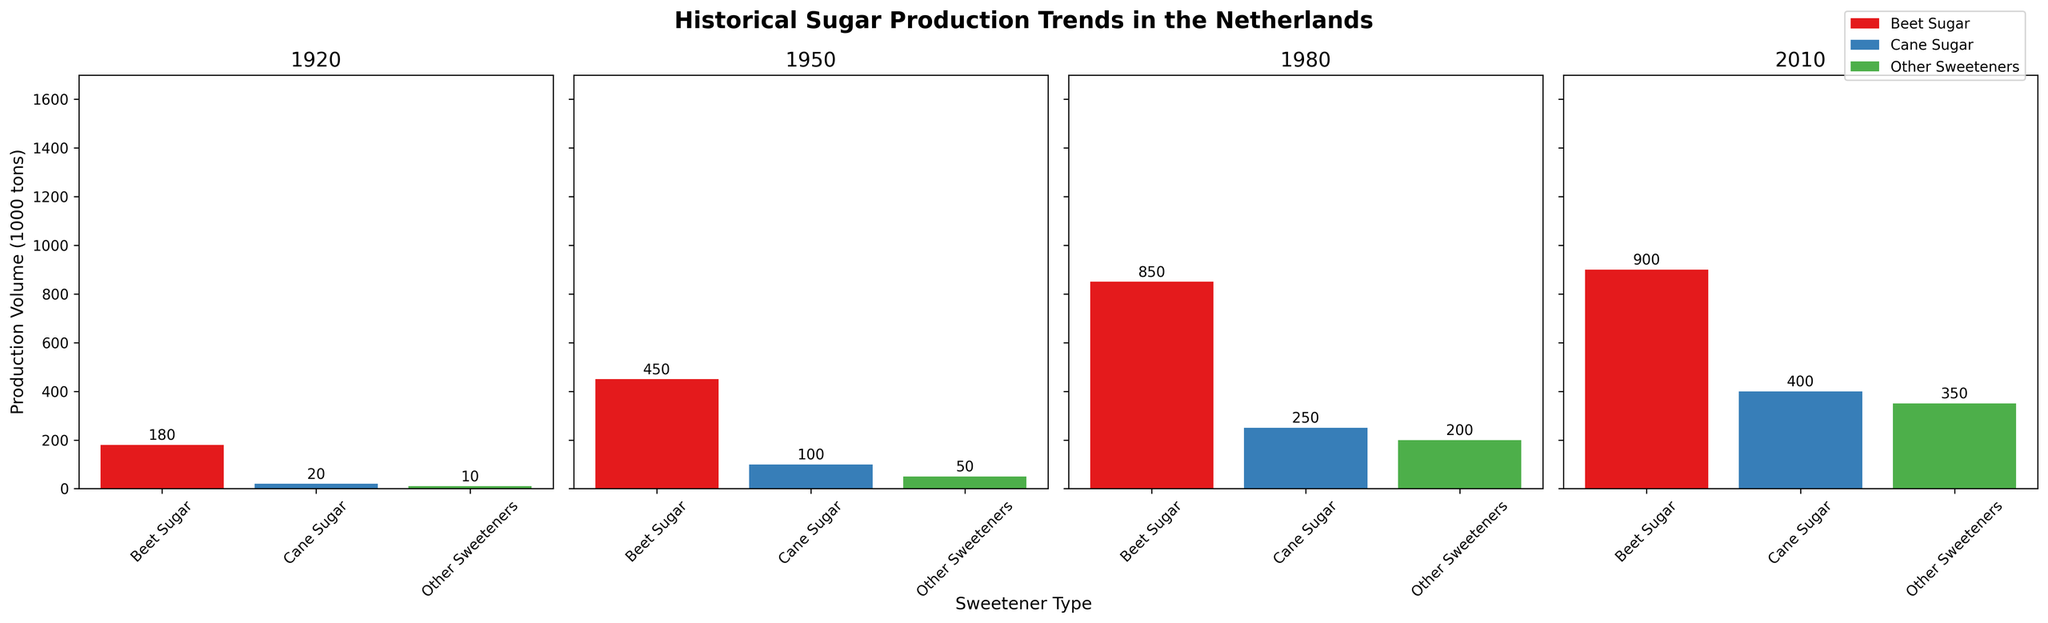what is the production volume of beet sugar in 1920? The first subplot labeled 1920 shows Beet Sugar with a bar height representing the production volume. This height corresponds to 180 thousand tons.
Answer: 180 What are the different sweetener types shown across all subplots? The legend at the top right of the figure lists all sweetener types. They are Beet Sugar, Cane Sugar, and Other Sweeteners.
Answer: Beet Sugar, Cane Sugar, Other Sweeteners How has the production volume of Other Sweeteners changed from 1920 to 2010? By comparing the heights of the bars for Other Sweeteners in the 1920 and 2010 subplots, we see that in 1920, the volume is 10 thousand tons, and in 2010, it is 350 thousand tons. The change is a 340 thousand tons increase.
Answer: Increased by 340 thousand tons Which year had the highest total production volume for all sweeteners combined? By summing the heights of all bars in each subplot: 
1920: 180 + 20 + 10 = 210 thousand tons 
1950: 450 + 100 + 50 = 600 thousand tons 
1980: 850 + 250 + 200 = 1300 thousand tons 
2010: 900 + 400 + 350 = 1650 thousand tons 
The highest is in 2010.
Answer: 2010 By what percentage did the market share of beet sugar decrease from 1950 to 2010? According to the y-labels in each subplot: 
1950 - Beet Sugar market share: 75% 
2010 - Beet Sugar market share: 55% 
Percentage decrease = (75% - 55%) = 20%
Answer: 20% Compare the production volumes of two largest sweeteners in 2010. Which one is higher? In the 2010 subplot, the production volumes for Beet Sugar and Cane Sugar are 900 thousand tons and 400 thousand tons, respectively. Thus, Beet Sugar has a higher production volume.
Answer: Beet Sugar What was the production volume difference between Beet Sugar and Cane Sugar in 1980? In the 1980 subplot, Beet Sugar has a production volume of 850 thousand tons, while Cane Sugar has 250 thousand tons. Difference = 850 - 250 = 600 thousand tons.
Answer: 600 Which sweetener type experienced the greatest increase in production volume from 1920 to 2010? Comparing production volumes in 1920 and 2010 for each sweetener type: 
Beet Sugar: 900 - 180 = 720 
Cane Sugar: 400 - 20 = 380 
Other Sweeteners: 350 - 10 = 340 
Beet Sugar experienced the greatest increase.
Answer: Beet Sugar What is the average production volume of Cane Sugar from 1920 to 2010? The production volumes for Cane Sugar are: 20, 100, 250, and 400. 
Sum = 20 + 100 + 250 + 400 = 770 
Average = 770 / 4 = 192.5
Answer: 192.5 In which decade did the production volume of Other Sweeteners surpass that of Cane Sugar? We need to look at each year's subplot. 
In 1920, Other Sweeteners (10) < Cane Sugar (20) 
In 1950, Other Sweeteners (50) < Cane Sugar (100) 
In 1980, Other Sweeteners (200) < Cane Sugar (250) 
In 2010, Other Sweeteners (350) > Cane Sugar (400) 
So, in 2010, Other Sweeteners surpassed Cane Sugar.
Answer: 2010 